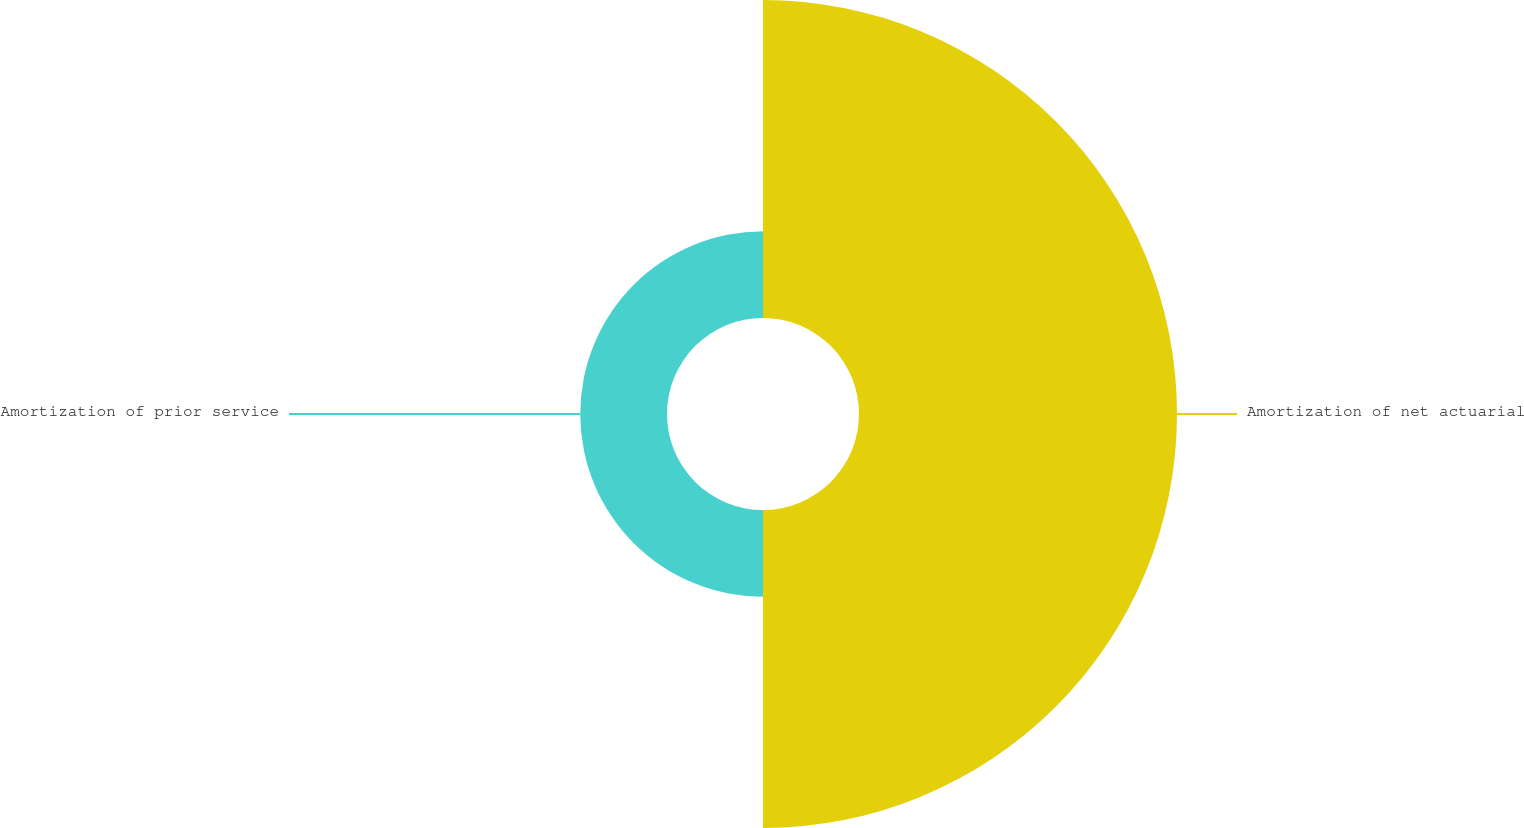<chart> <loc_0><loc_0><loc_500><loc_500><pie_chart><fcel>Amortization of net actuarial<fcel>Amortization of prior service<nl><fcel>78.57%<fcel>21.43%<nl></chart> 